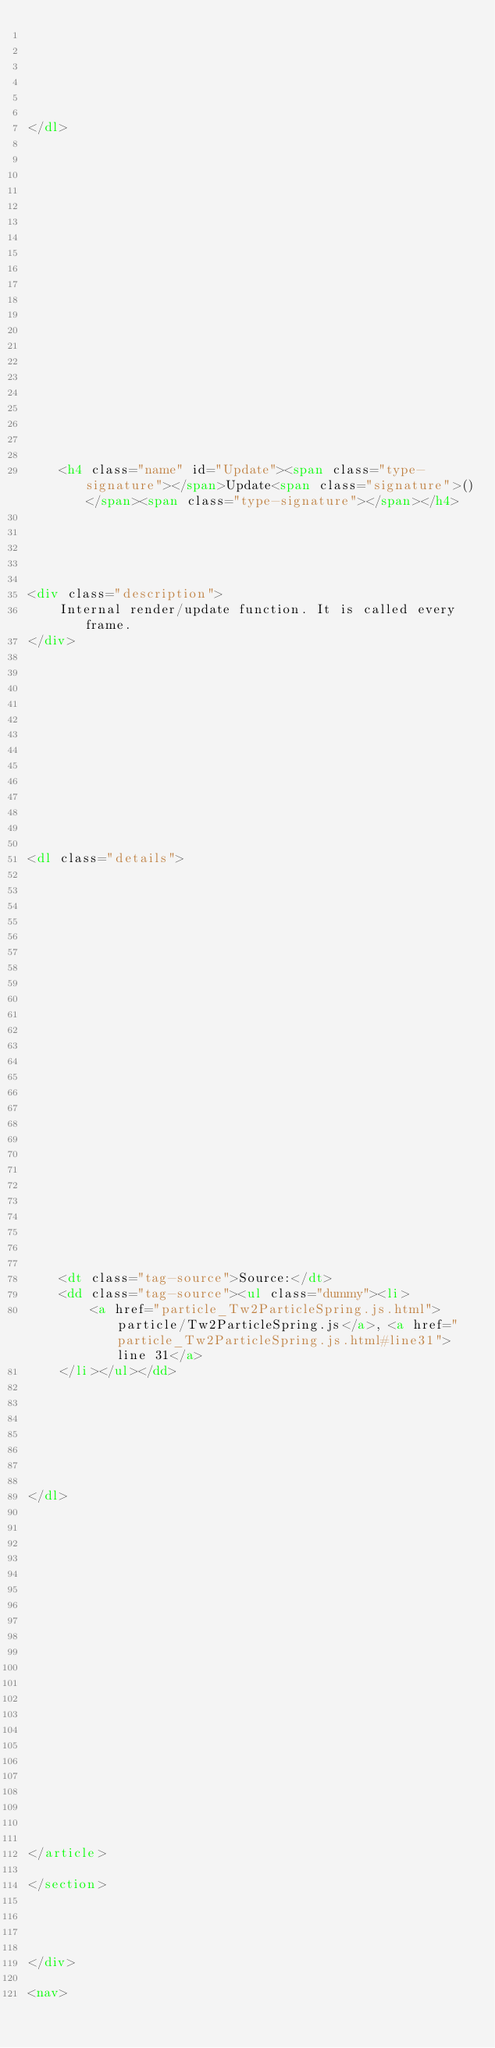<code> <loc_0><loc_0><loc_500><loc_500><_HTML_>
    

    

    
</dl>
















        
            

    

    <h4 class="name" id="Update"><span class="type-signature"></span>Update<span class="signature">()</span><span class="type-signature"></span></h4>

    



<div class="description">
    Internal render/update function. It is called every frame.
</div>













<dl class="details">

    

    

    

    

    

    

    

    

    

    

    

    

    
    <dt class="tag-source">Source:</dt>
    <dd class="tag-source"><ul class="dummy"><li>
        <a href="particle_Tw2ParticleSpring.js.html">particle/Tw2ParticleSpring.js</a>, <a href="particle_Tw2ParticleSpring.js.html#line31">line 31</a>
    </li></ul></dd>
    

    

    

    
</dl>
















        
    

    

    
</article>

</section>




</div>

<nav></code> 